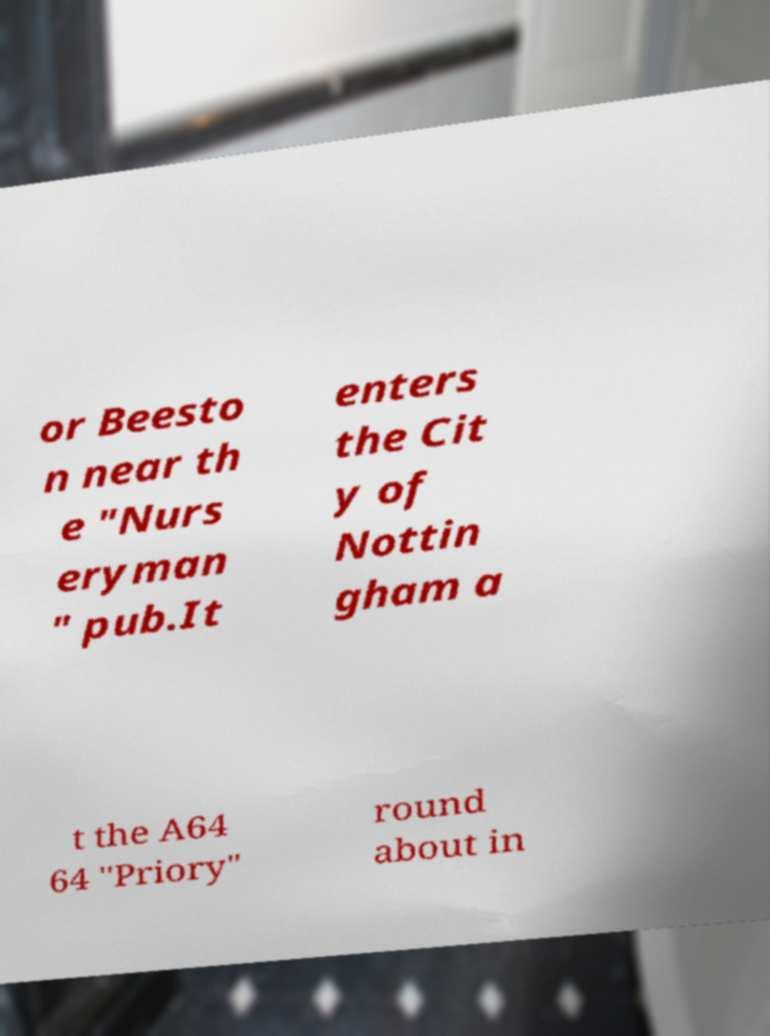Please identify and transcribe the text found in this image. or Beesto n near th e "Nurs eryman " pub.It enters the Cit y of Nottin gham a t the A64 64 "Priory" round about in 